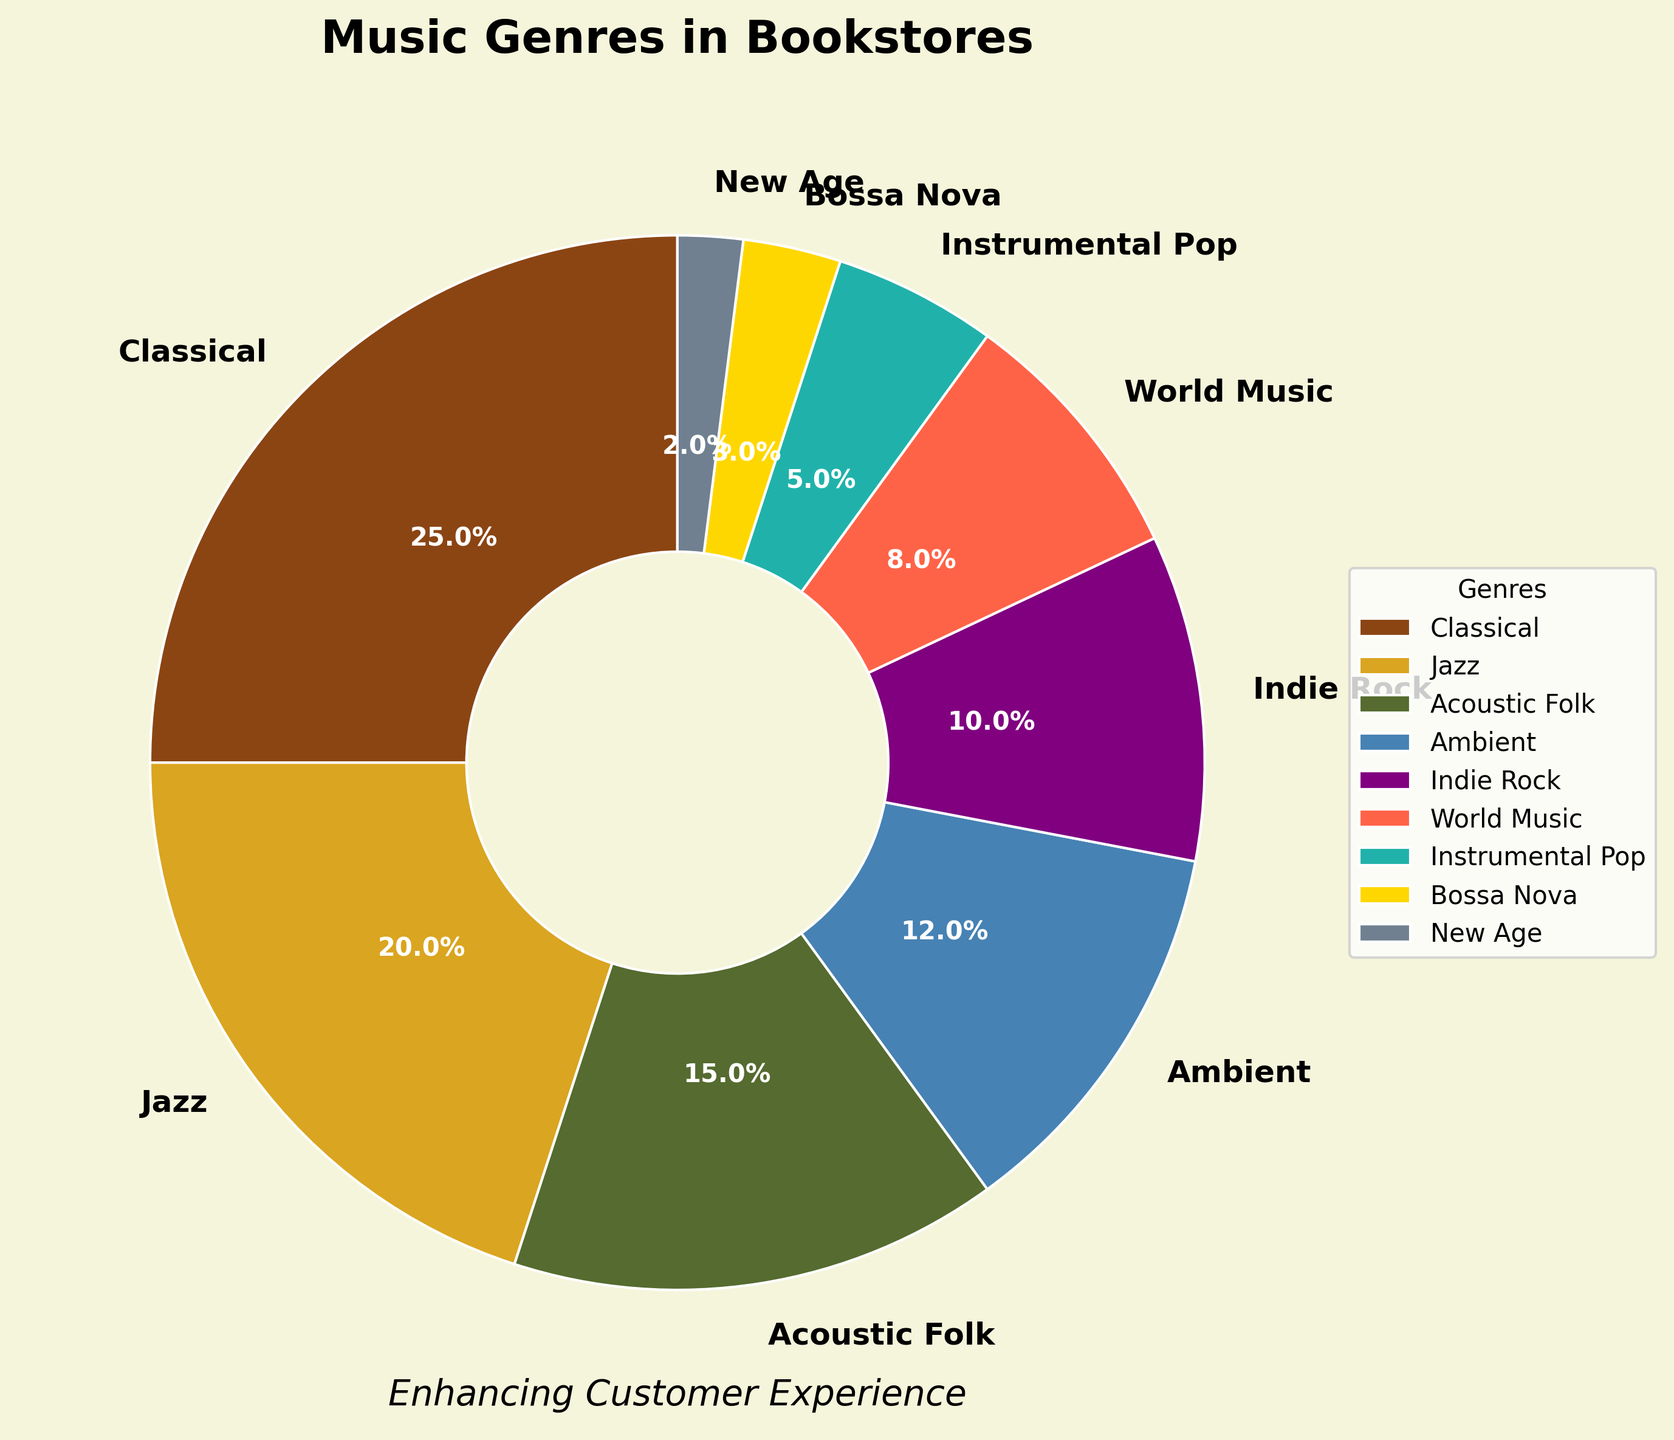Which genre takes up the largest section of the pie chart? The largest section of the pie chart represents the genre with the highest percentage. From the data, Classical music has the highest percentage at 25%.
Answer: Classical Compare Jazz and Indie Rock: which one has a higher representation in the pie chart? By examining the percentages, Jazz has a representation of 20%, whereas Indie Rock has 10%. Since 20% is greater than 10%, Jazz has a higher representation in the pie chart.
Answer: Jazz What's the combined percentage of Ambient, World Music, and Bossa Nova? To find the combined percentage, sum the percentages of each genre: Ambient (12%) + World Music (8%) + Bossa Nova (3%) = 12% + 8% + 3% = 23%.
Answer: 23% Which genre has the closest percentage to Acoustic Folk? Acoustic Folk is at 15%. The closest percentage to 15% is Jazz at 20%.
Answer: Jazz What is the difference in percentage between Instrumental Pop and New Age? Instrumental Pop is 5% and New Age is 2%. The difference is 5% - 2% = 3%.
Answer: 3% How many genres have a percentage representation of 10% or more? The genres with percentages of 10% or more are Classical (25%), Jazz (20%), Acoustic Folk (15%), and Indie Rock (10%). There are four genres in total.
Answer: 4 Among the categories, which one has the smallest wedge in the pie chart? The smallest wedge represents the genre with the lowest percentage. From the data, New Age has the smallest percentage at 2%.
Answer: New Age By how much does Classical music exceed World Music in percentage representation? Classical music has 25% while World Music has 8%. The difference is 25% - 8% = 17%.
Answer: 17% Is there any genre similar in representation to Instrumental Pop? Instrumental Pop has a percentage of 5%. Bossa Nova has a similar representation, albeit slightly lower, at 3%.
Answer: Bossa Nova 